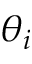<formula> <loc_0><loc_0><loc_500><loc_500>\theta _ { i }</formula> 